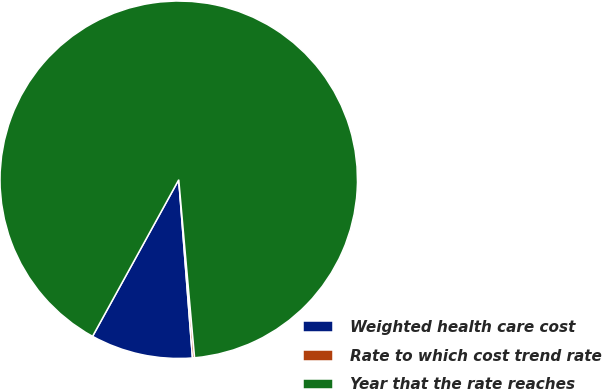Convert chart. <chart><loc_0><loc_0><loc_500><loc_500><pie_chart><fcel>Weighted health care cost<fcel>Rate to which cost trend rate<fcel>Year that the rate reaches<nl><fcel>9.23%<fcel>0.19%<fcel>90.57%<nl></chart> 